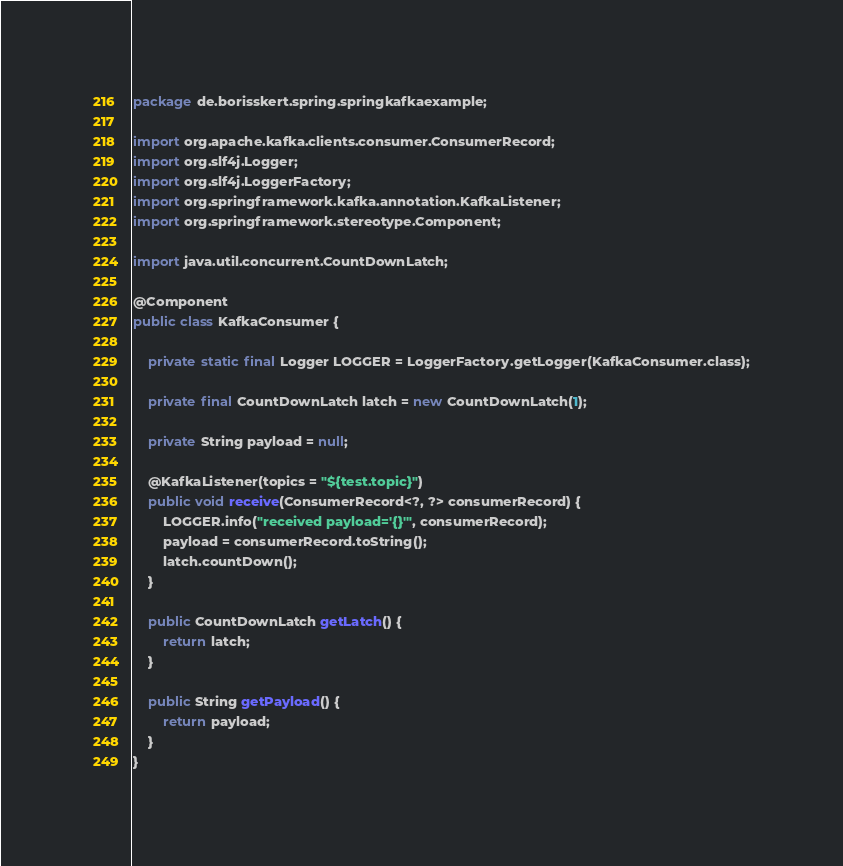Convert code to text. <code><loc_0><loc_0><loc_500><loc_500><_Java_>package de.borisskert.spring.springkafkaexample;

import org.apache.kafka.clients.consumer.ConsumerRecord;
import org.slf4j.Logger;
import org.slf4j.LoggerFactory;
import org.springframework.kafka.annotation.KafkaListener;
import org.springframework.stereotype.Component;

import java.util.concurrent.CountDownLatch;

@Component
public class KafkaConsumer {

    private static final Logger LOGGER = LoggerFactory.getLogger(KafkaConsumer.class);

    private final CountDownLatch latch = new CountDownLatch(1);

    private String payload = null;

    @KafkaListener(topics = "${test.topic}")
    public void receive(ConsumerRecord<?, ?> consumerRecord) {
        LOGGER.info("received payload='{}'", consumerRecord);
        payload = consumerRecord.toString();
        latch.countDown();
    }

    public CountDownLatch getLatch() {
        return latch;
    }

    public String getPayload() {
        return payload;
    }
}
</code> 